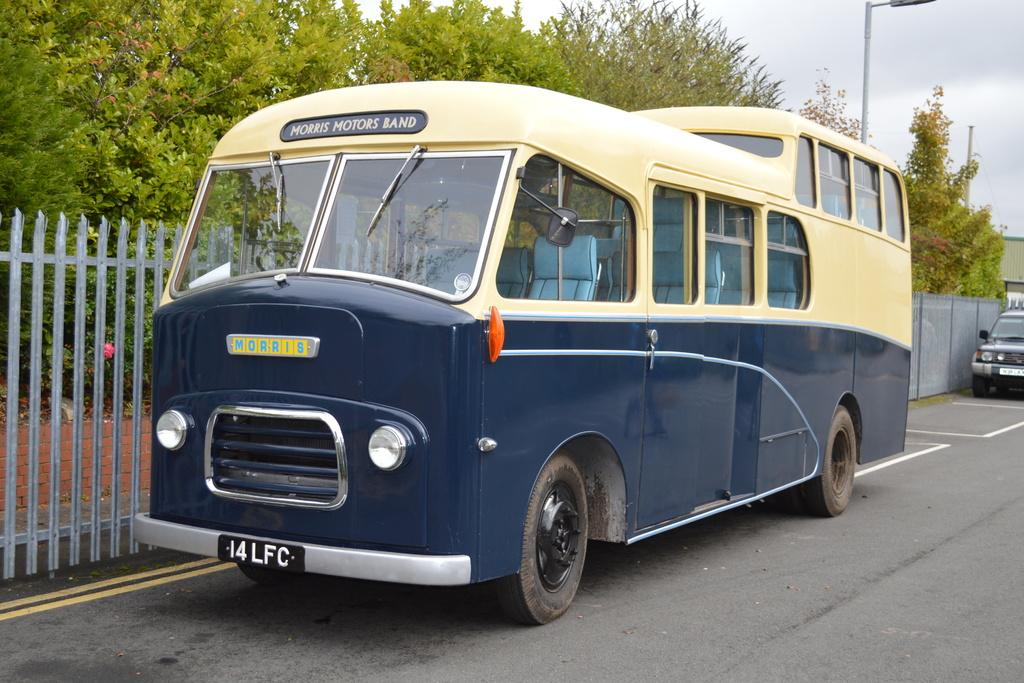What type of vehicle can be seen in the image? There is a bus in the image. Are there any other vehicles present in the image? Yes, there is a car in the image. Where are the bus and car located? Both the bus and car are on the road. What can be seen in the background of the image? There is a fence, trees, houses, a street light, and the sky visible in the background of the image. Can you describe the time of day when the image was taken? The image was taken during the day. What type of cloth is being used to cover the drain in the image? There is no drain or cloth present in the image. Who is the manager of the bus in the image? There is no indication of a bus manager in the image. 